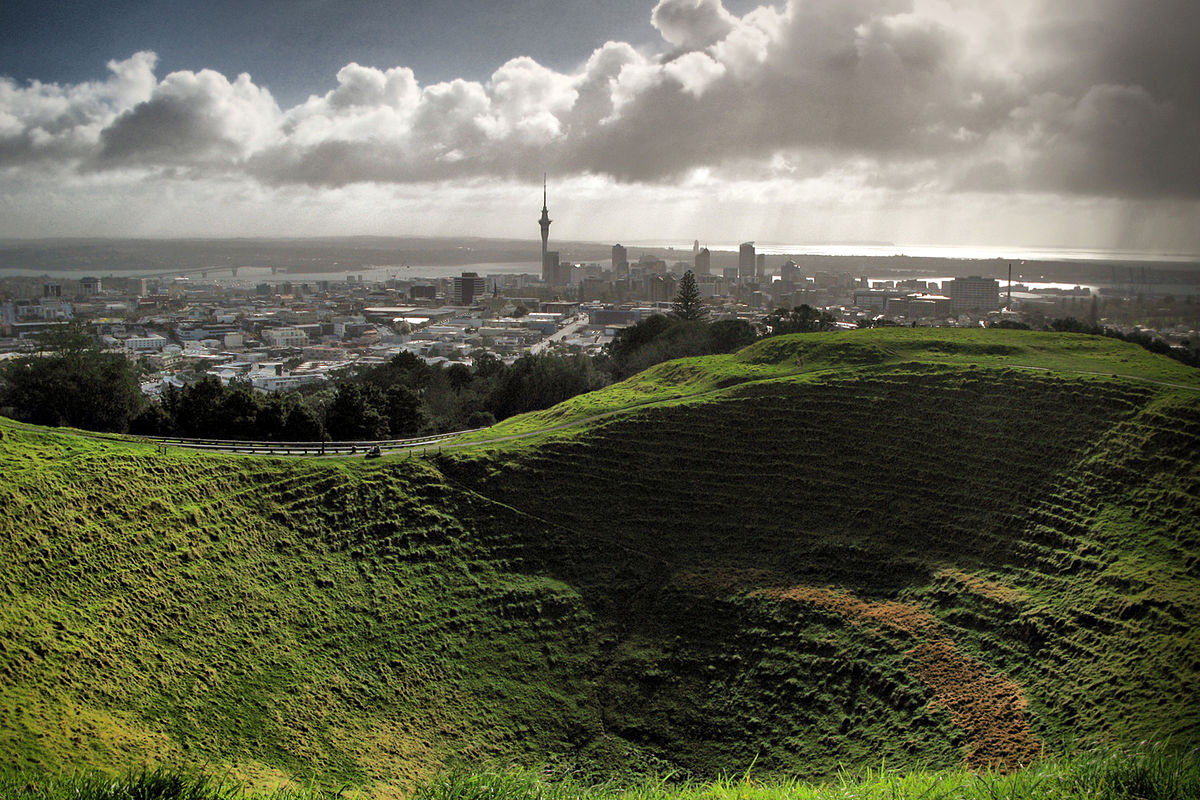How does the presence of the crater influence the urban development around it? The Mt Eden Crater, being a preserved natural landmark, significantly influences urban planning around it. The area surrounding the crater is kept largely undeveloped to protect the natural heritage and to provide a recreational space for residents and visitors. This restriction in development can lead to higher property values in the surrounding areas due to the proximity to a major natural attraction and the limited space available for construction. 